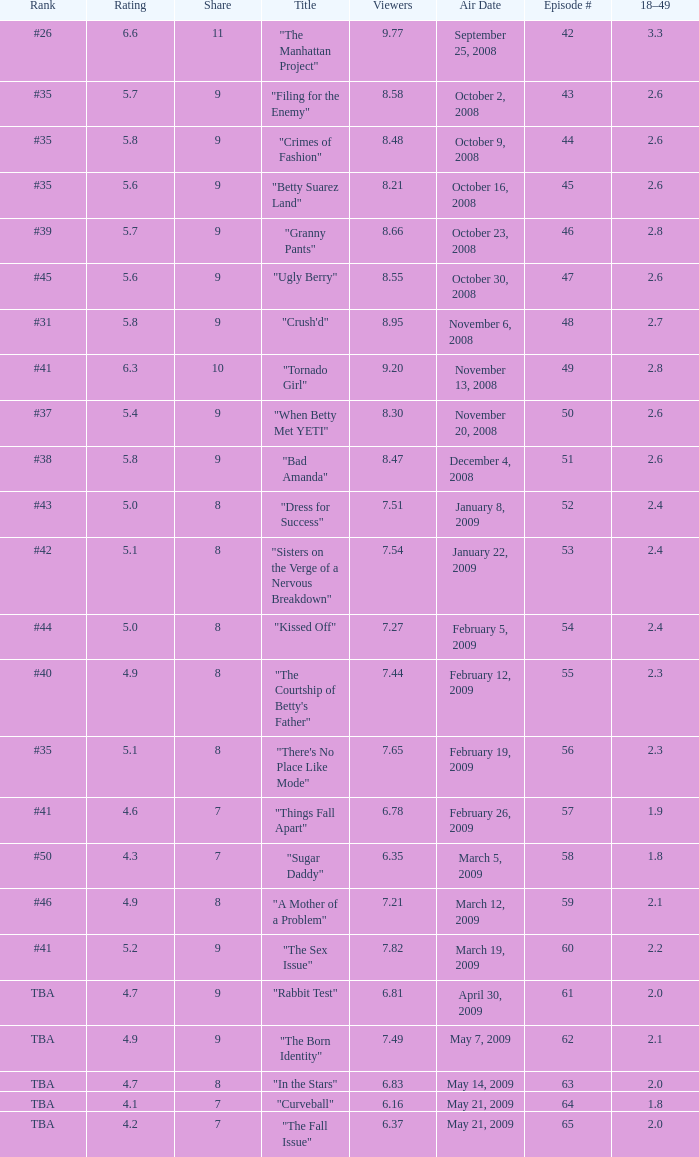What is the lowest Viewers that has an Episode #higher than 58 with a title of "curveball" less than 4.1 rating? None. 